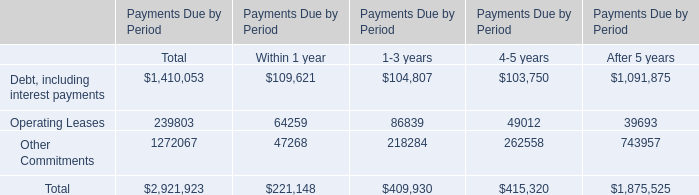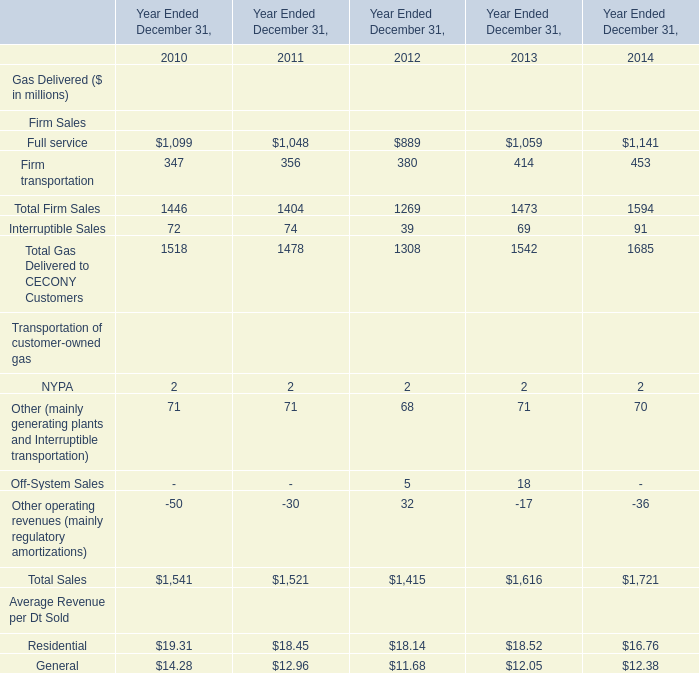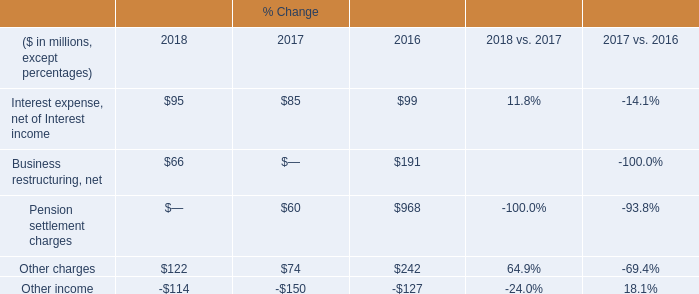What was the average value of the Other (mainly generating plants and Interruptible transportation) in the years where Off-System Sales is positive? (in million) 
Computations: ((68 + 71) / 2)
Answer: 69.5. 